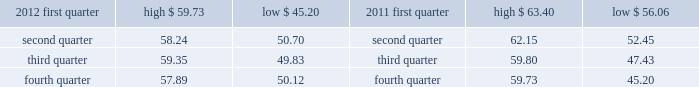( 5 ) we occupy approximately 350000 square feet of the one north end building .
( 6 ) this property is owned by board of trade investment company ( botic ) .
Kcbt maintains a 51% ( 51 % ) controlling interest in botic .
We also lease other office space around the world and have also partnered with major global telecommunications carriers in connection with our telecommunications hubs whereby we place data cabinets within the carriers 2019 existing secured data centers .
We believe our facilities are adequate for our current operations and that additional space can be obtained if needed .
Item 3 .
Legal proceedings see 201clegal and regulatory matters 201d in note 14 .
Contingencies to the consolidated financial statements beginning on page 91 for cme group 2019s legal proceedings disclosure which is incorporated herein by reference .
Item 4 .
Mine safety disclosures not applicable .
Part ii item 5 .
Market for registrant 2019s common equity , related stockholder matters and issuer purchases of equity securities class a common stock our class a common stock is currently listed on nasdaq under the ticker symbol 201ccme . 201d as of february 13 , 2013 , there were approximately 3106 holders of record of our class a common stock .
In may 2012 , the company 2019s board of directors declared a five-for-one split of its class a common stock effected by way of a stock dividend to its class a and class b shareholders .
The stock split was effective july 20 , 2012 for all shareholders of record on july 10 , 2012 .
As a result of the stock split , all amounts related to shares and per share amounts have been retroactively restated .
The table sets forth the high and low sales prices per share of our class a common stock on a quarterly basis , as reported on nasdaq. .
Class b common stock our class b common stock is not listed on a national securities exchange or traded in an organized over- the-counter market .
Each class of our class b common stock is associated with a membership in a specific division of our cme exchange .
Cme 2019s rules provide exchange members with trading rights and the ability to use or lease these trading rights .
Each share of our class b common stock can be transferred only in connection with the transfer of the associated trading rights. .
What was the average sales price for the class b common shares in 2012 in the first quarter? 
Computations: (((59.73 + 45.20) + 2) / 2)
Answer: 53.465. 